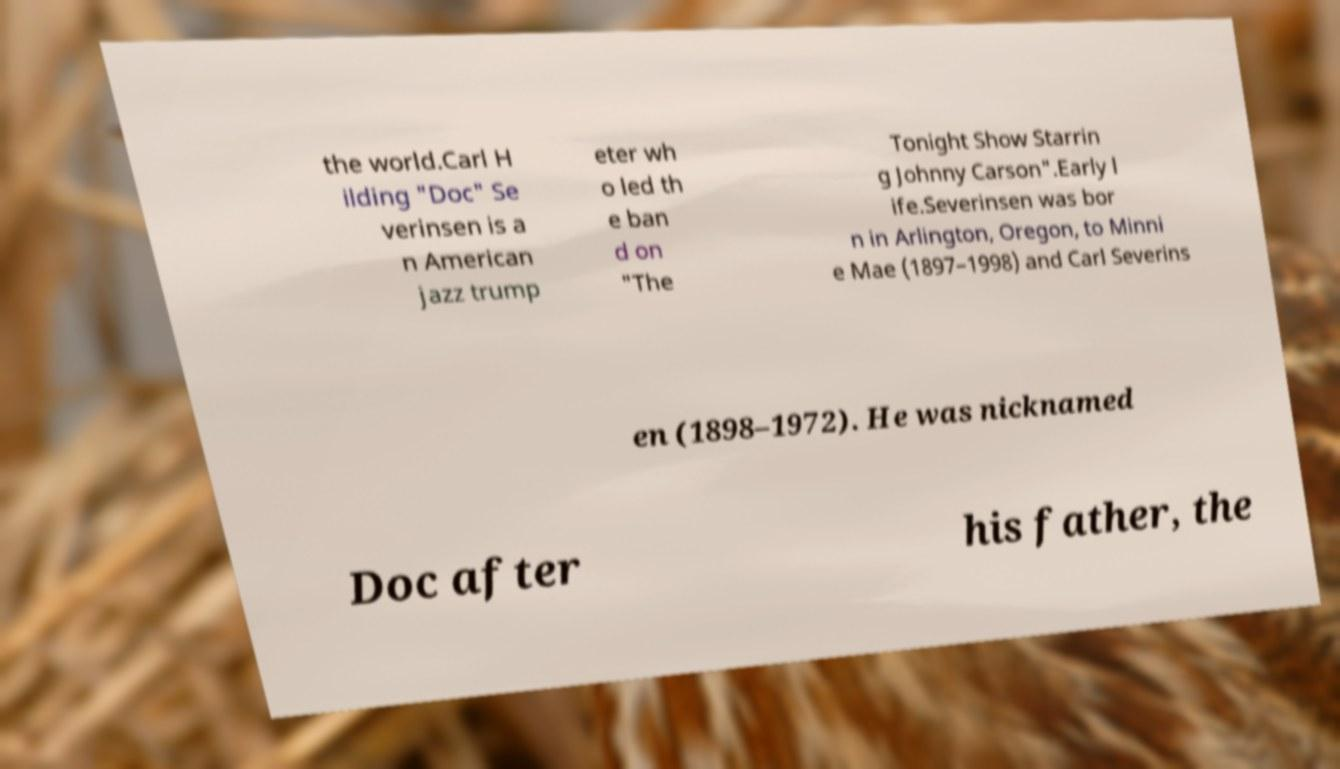For documentation purposes, I need the text within this image transcribed. Could you provide that? the world.Carl H ilding "Doc" Se verinsen is a n American jazz trump eter wh o led th e ban d on "The Tonight Show Starrin g Johnny Carson".Early l ife.Severinsen was bor n in Arlington, Oregon, to Minni e Mae (1897–1998) and Carl Severins en (1898–1972). He was nicknamed Doc after his father, the 